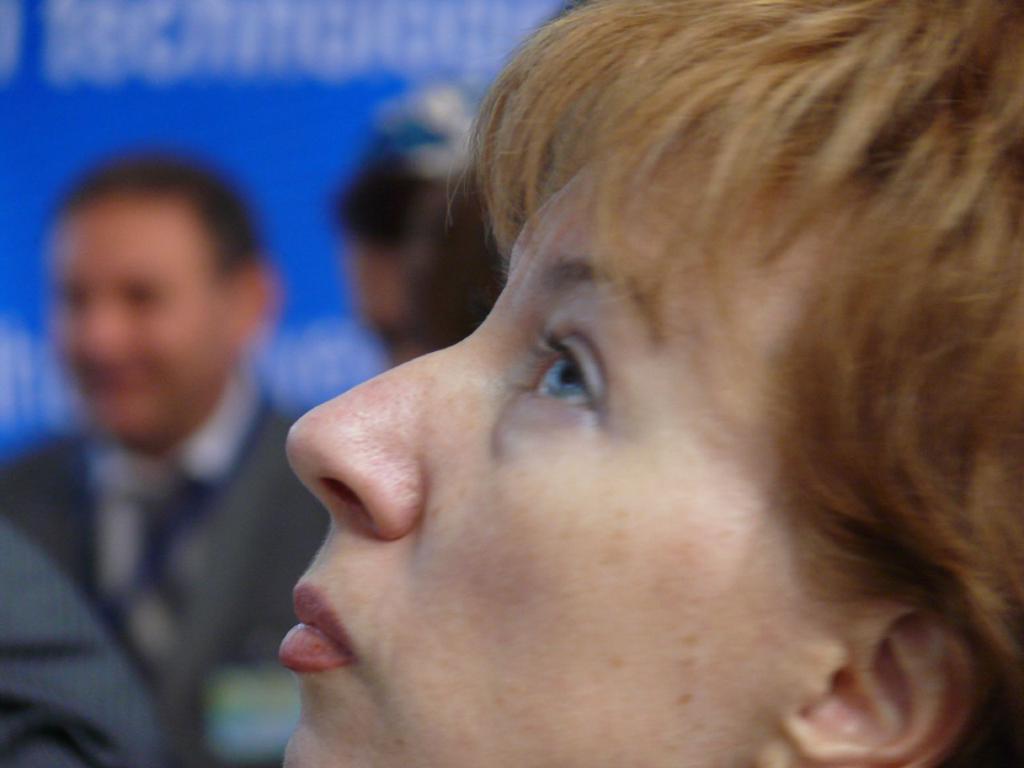In one or two sentences, can you explain what this image depicts? This is the zoom-in picture of a face of a woman. In the background, we can see people and a banner with some text. 